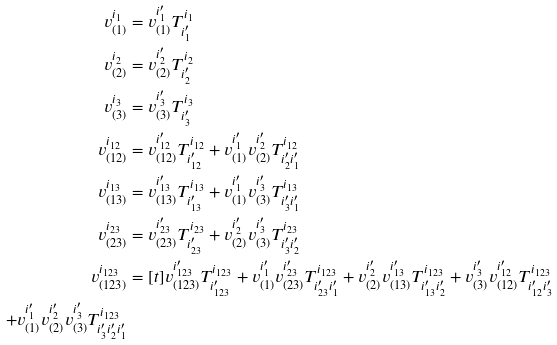<formula> <loc_0><loc_0><loc_500><loc_500>v ^ { i _ { 1 } } _ { ( 1 ) } & = v ^ { i _ { 1 } ^ { \prime } } _ { ( 1 ) } T _ { i _ { 1 } ^ { \prime } } ^ { i _ { 1 } } \\ v ^ { i _ { 2 } } _ { ( 2 ) } & = v ^ { i _ { 2 } ^ { \prime } } _ { ( 2 ) } T _ { i _ { 2 } ^ { \prime } } ^ { i _ { 2 } } \\ v ^ { i _ { 3 } } _ { ( 3 ) } & = v ^ { i _ { 3 } ^ { \prime } } _ { ( 3 ) } T _ { i _ { 3 } ^ { \prime } } ^ { i _ { 3 } } \\ v ^ { i _ { 1 2 } } _ { ( 1 2 ) } & = v ^ { i _ { 1 2 } ^ { \prime } } _ { ( 1 2 ) } T _ { i _ { 1 2 } ^ { \prime } } ^ { i _ { 1 2 } } + v ^ { i _ { 1 } ^ { \prime } } _ { ( 1 ) } v ^ { i _ { 2 } ^ { \prime } } _ { ( 2 ) } T _ { { i _ { 2 } ^ { \prime } } { i _ { 1 } ^ { \prime } } } ^ { i _ { 1 2 } } \\ v ^ { i _ { 1 3 } } _ { ( 1 3 ) } & = v ^ { i _ { 1 3 } ^ { \prime } } _ { ( 1 3 ) } T _ { i _ { 1 3 } ^ { \prime } } ^ { i _ { 1 3 } } + v ^ { i _ { 1 } ^ { \prime } } _ { ( 1 ) } v ^ { i _ { 3 } ^ { \prime } } _ { ( 3 ) } T _ { { i _ { 3 } ^ { \prime } } { i _ { 1 } ^ { \prime } } } ^ { i _ { 1 3 } } \\ v ^ { i _ { 2 3 } } _ { ( 2 3 ) } & = v ^ { i _ { 2 3 } ^ { \prime } } _ { ( 2 3 ) } T _ { i _ { 2 3 } ^ { \prime } } ^ { i _ { 2 3 } } + v ^ { i _ { 2 } ^ { \prime } } _ { ( 2 ) } v ^ { i _ { 3 } ^ { \prime } } _ { ( 3 ) } T _ { { i _ { 3 } ^ { \prime } } { i _ { 2 } ^ { \prime } } } ^ { i _ { 2 3 } } \\ v ^ { i _ { 1 2 3 } } _ { ( 1 2 3 ) } & = [ t ] v ^ { i _ { 1 2 3 } ^ { \prime } } _ { ( 1 2 3 ) } T _ { i _ { 1 2 3 } ^ { \prime } } ^ { i _ { 1 2 3 } } + v ^ { i _ { 1 } ^ { \prime } } _ { ( 1 ) } v ^ { i _ { 2 3 } ^ { \prime } } _ { ( 2 3 ) } T _ { { i _ { 2 3 } ^ { \prime } } { i _ { 1 } ^ { \prime } } } ^ { i _ { 1 2 3 } } + v ^ { i _ { 2 } ^ { \prime } } _ { ( 2 ) } v ^ { i _ { 1 3 } ^ { \prime } } _ { ( 1 3 ) } T _ { { i _ { 1 3 } ^ { \prime } } { i _ { 2 } ^ { \prime } } } ^ { i _ { 1 2 3 } } + v ^ { i _ { 3 } ^ { \prime } } _ { ( 3 ) } v ^ { i _ { 1 2 } ^ { \prime } } _ { ( 1 2 ) } T _ { { i _ { 1 2 } ^ { \prime } } { i _ { 3 } ^ { \prime } } } ^ { i _ { 1 2 3 } } \\ + v ^ { i _ { 1 } ^ { \prime } } _ { ( 1 ) } v ^ { i _ { 2 } ^ { \prime } } _ { ( 2 ) } v ^ { i _ { 3 } ^ { \prime } } _ { ( 3 ) } T _ { { i _ { 3 } ^ { \prime } } { i _ { 2 } ^ { \prime } } { i _ { 1 } ^ { \prime } } } ^ { i _ { 1 2 3 } }</formula> 